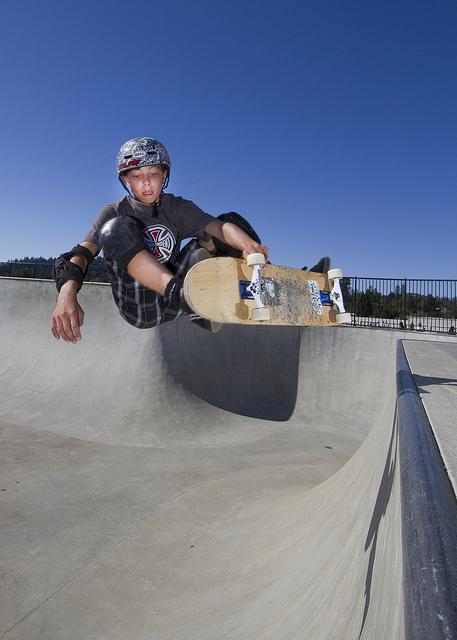Is the boy wearing a helmet?
Answer briefly. Yes. Is he high?
Give a very brief answer. Yes. What is the boy doing?
Give a very brief answer. Skateboarding. 